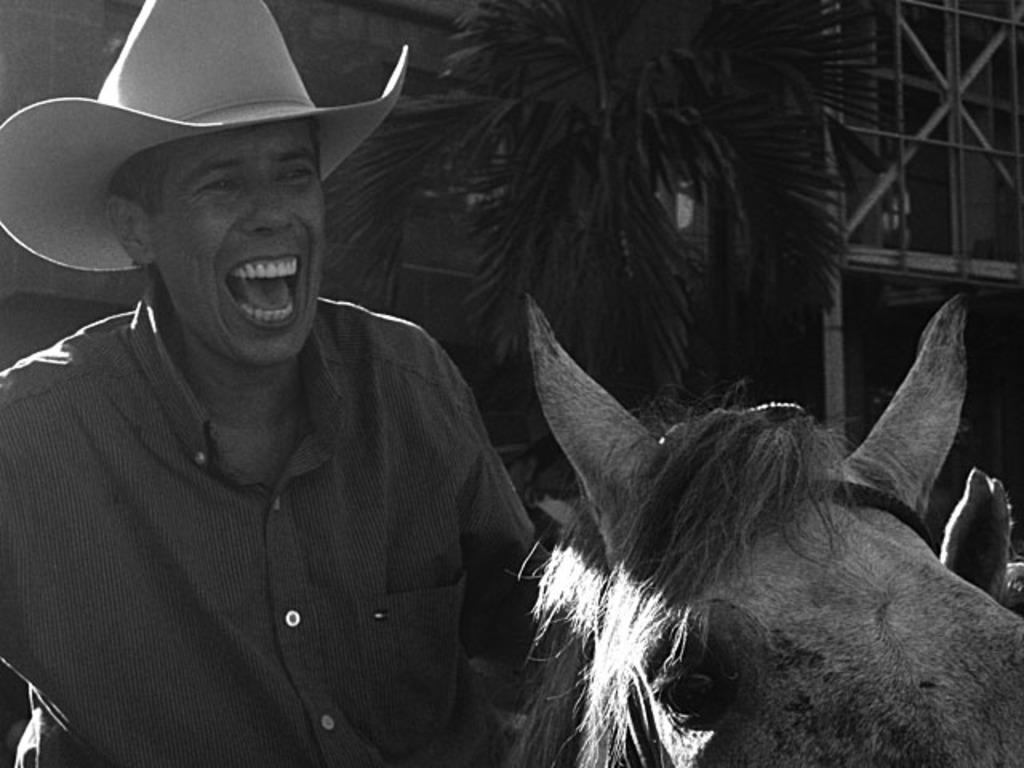What can be seen in the image? There is a person in the image. What is the person wearing? The person is wearing a hat. What is located on the right side of the image? There is a horse on the right side of the image. What can be seen in the background of the image? There are trees and a building in the background of the image. What type of drain is visible in the image? There is no drain present in the image. How many drops of water can be seen falling from the hat in the image? There are no drops of water visible in the image, and the person is wearing a hat, not a water-collecting object. 